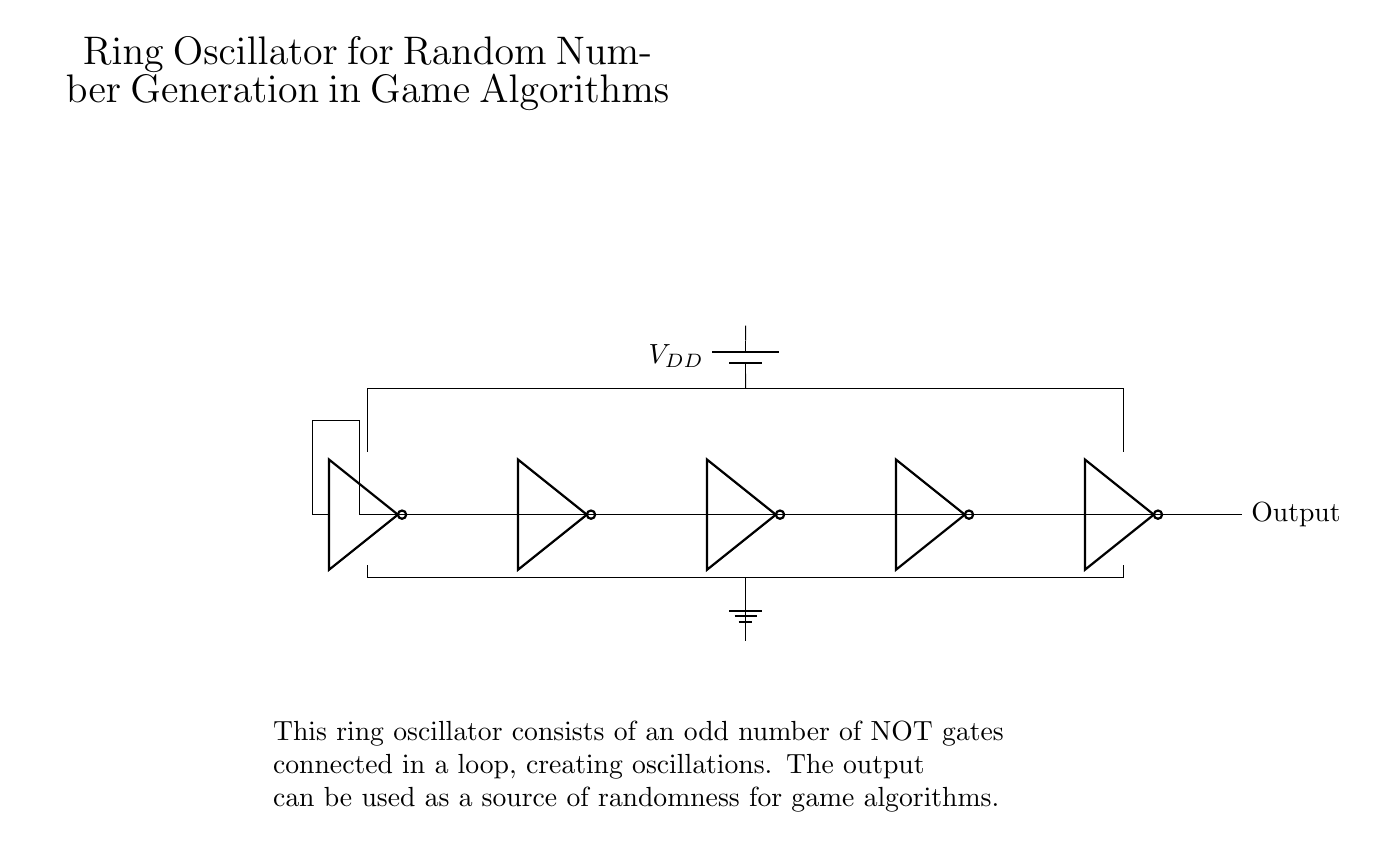What components are used in this ring oscillator? The circuit consists of five NOT gates connected in a loop, which serve as the primary components for oscillation.
Answer: Five NOT gates What is the purpose of the battery in the circuit? The battery provides the necessary voltage supply (VDD) to power the NOT gates, enabling them to operate and produce oscillations.
Answer: Voltage supply How many NOT gates are in the circuit? There are five NOT gates, which are arranged in a closed loop to create oscillations.
Answer: Five What type of signal does the output provide? The output produces a digital square wave signal, which shifts between high and low states due to the oscillation of the NOT gates.
Answer: Square wave signal Why does the ring oscillator require an odd number of NOT gates? An odd number of NOT gates is necessary to ensure that the feedback in the loop does not stabilize at either a high or low state, allowing continuous oscillation.
Answer: Odd number for stability What is the function of the ground connection in the circuit? The ground connection provides a reference point for the circuit's electrical potential, which allows the NOT gates to operate according to the supplied voltage (VDD) and ensures proper circuit functioning.
Answer: Reference point 